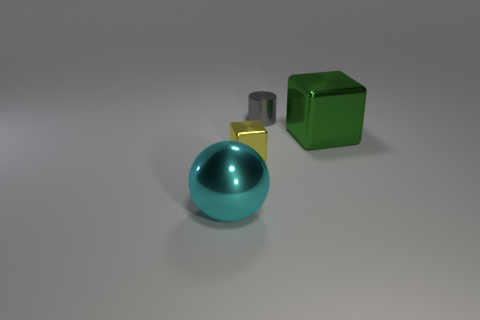Add 2 large cyan metal blocks. How many objects exist? 6 Subtract all spheres. How many objects are left? 3 Add 2 green things. How many green things are left? 3 Add 2 large green metallic things. How many large green metallic things exist? 3 Subtract 0 green cylinders. How many objects are left? 4 Subtract all big cyan balls. Subtract all tiny cylinders. How many objects are left? 2 